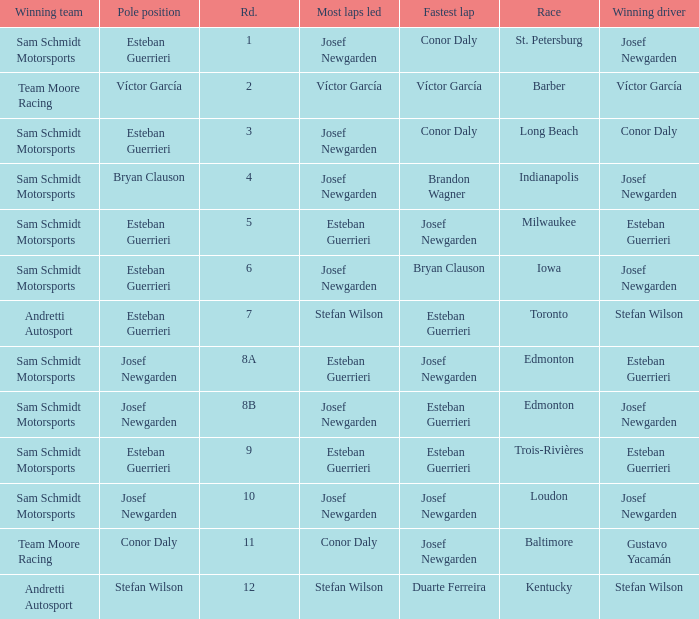Who had the pole(s) when esteban guerrieri led the most laps round 8a and josef newgarden had the fastest lap? Josef Newgarden. 